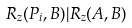<formula> <loc_0><loc_0><loc_500><loc_500>R _ { z } ( P _ { i } , B ) | R _ { z } ( A , B )</formula> 